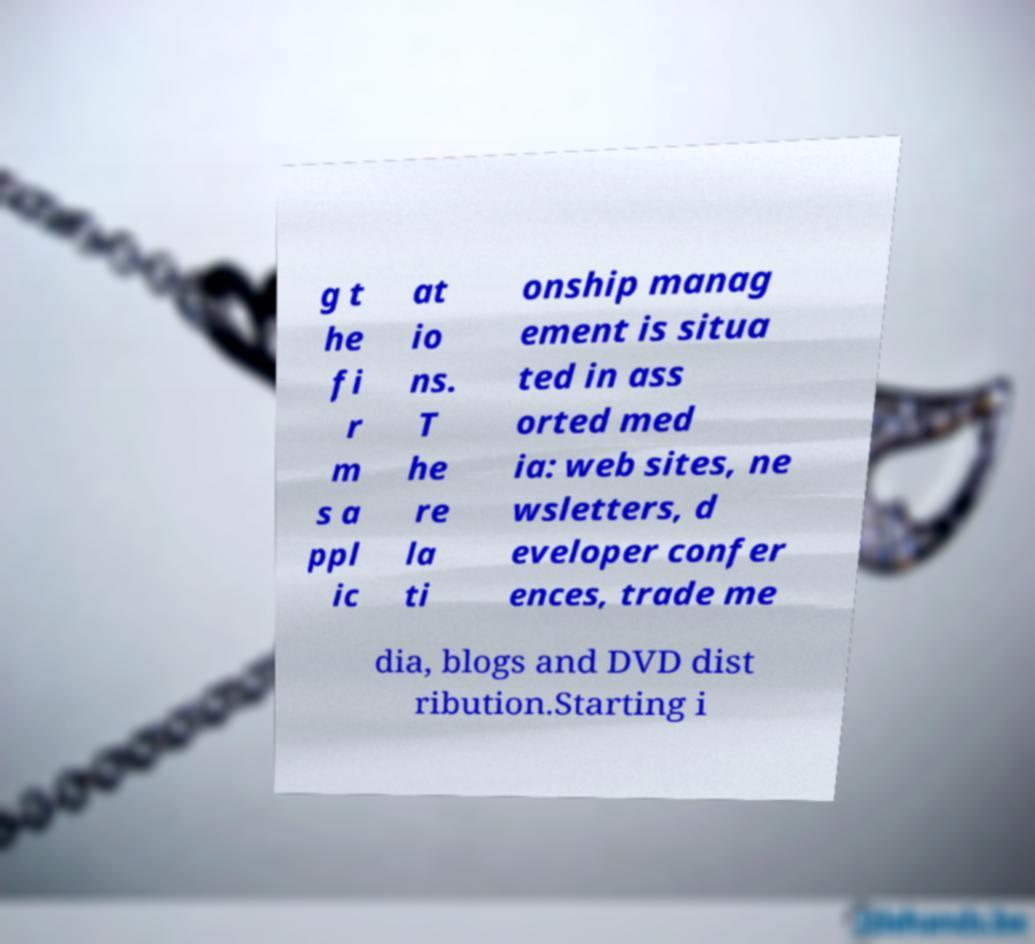Please identify and transcribe the text found in this image. g t he fi r m s a ppl ic at io ns. T he re la ti onship manag ement is situa ted in ass orted med ia: web sites, ne wsletters, d eveloper confer ences, trade me dia, blogs and DVD dist ribution.Starting i 